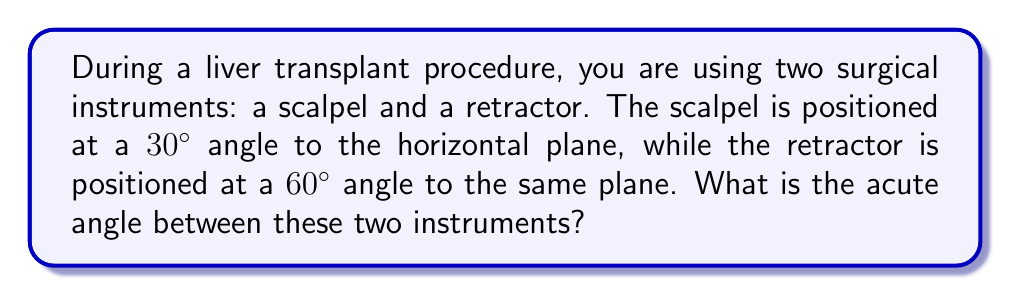What is the answer to this math problem? Let's approach this step-by-step:

1) We can visualize this problem as two lines in a 2D plane, where the horizontal plane is our reference line.

2) The scalpel forms a 30° angle with the horizontal, and the retractor forms a 60° angle with the horizontal.

3) To find the angle between the instruments, we need to subtract the smaller angle from the larger angle:

   $$\text{Angle between instruments} = |\text{Angle of retractor} - \text{Angle of scalpel}|$$

4) Substituting the values:

   $$\text{Angle between instruments} = |60° - 30°| = 30°$$

5) Therefore, the acute angle between the scalpel and the retractor is 30°.

[asy]
import geometry;

size(200);
draw((0,0)--(100,0),arrow=Arrow(TeXHead));
draw((0,0)--(86.6,50),arrow=Arrow(TeXHead));
draw((0,0)--(50,86.6),arrow=Arrow(TeXHead));

label("Horizontal", (100,-10));
label("Scalpel (30°)", (86.6,50), E);
label("Retractor (60°)", (50,86.6), N);

draw(arc((0,0),20,0,30),Arrow(TeXHead));
draw(arc((0,0),30,30,60),Arrow(TeXHead));

label("30°", (15,5));
label("30°", (22,22));
[/asy]
Answer: 30° 